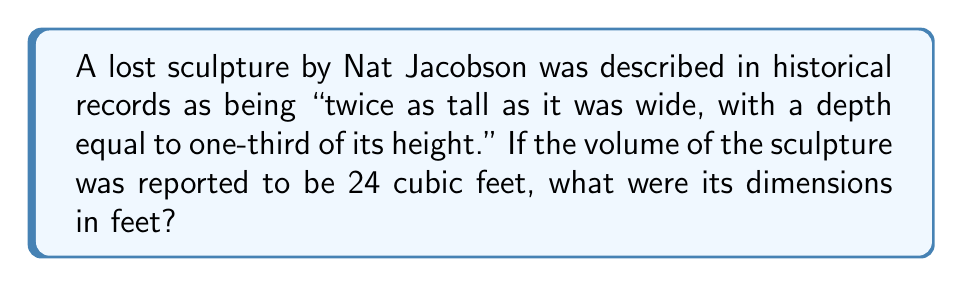Can you solve this math problem? Let's approach this step-by-step:

1) Let's define variables:
   $w$ = width
   $h$ = height
   $d$ = depth

2) From the description, we can establish relationships:
   $h = 2w$
   $d = \frac{1}{3}h = \frac{1}{3}(2w) = \frac{2}{3}w$

3) We know the volume is 24 cubic feet:
   $V = w \times h \times d = 24$

4) Substitute the relationships:
   $w \times 2w \times \frac{2}{3}w = 24$

5) Simplify:
   $\frac{4}{3}w^3 = 24$

6) Solve for $w$:
   $w^3 = 24 \times \frac{3}{4} = 18$
   $w = \sqrt[3]{18} \approx 2.621$ feet

7) Calculate $h$:
   $h = 2w \approx 5.242$ feet

8) Calculate $d$:
   $d = \frac{2}{3}w \approx 1.747$ feet

9) Round to two decimal places:
   $w \approx 2.62$ feet
   $h \approx 5.24$ feet
   $d \approx 1.75$ feet
Answer: 2.62 ft × 5.24 ft × 1.75 ft 